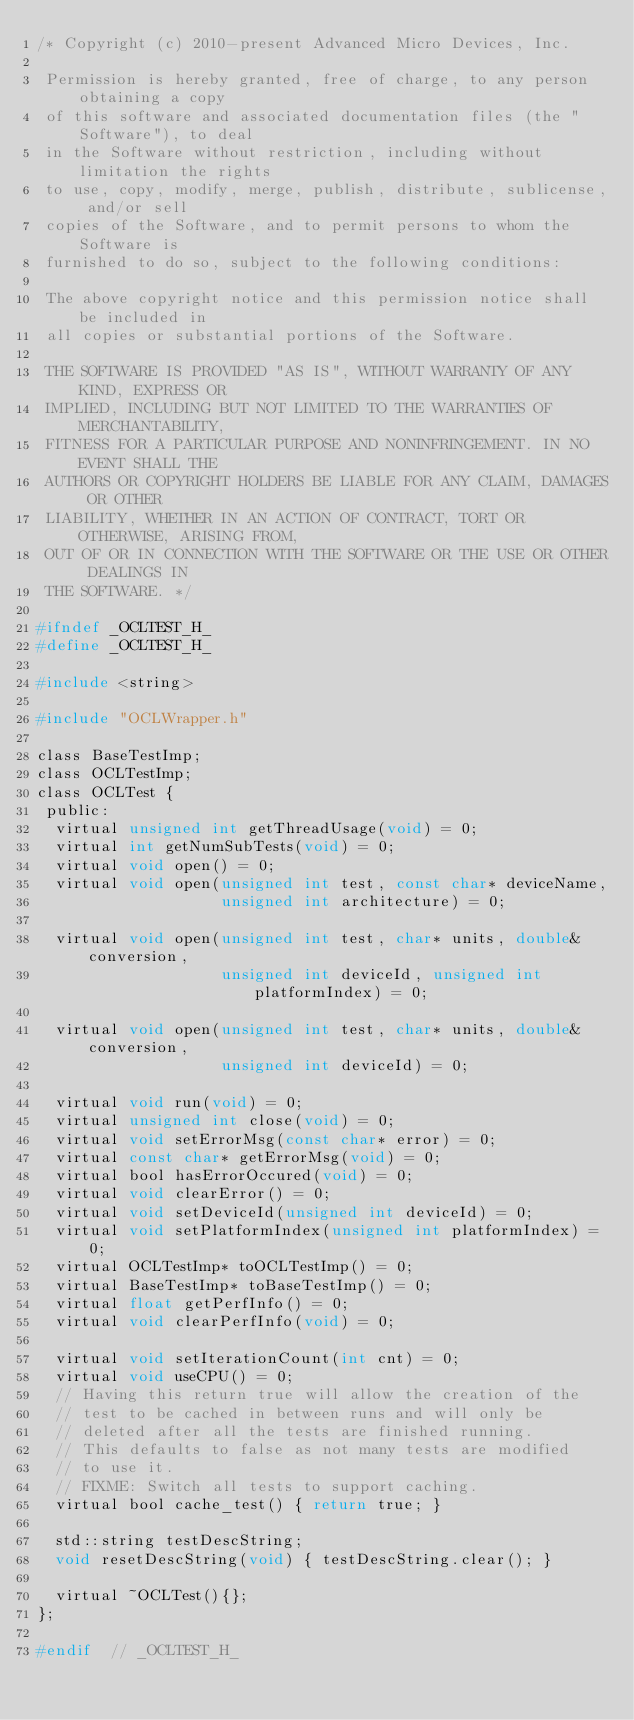<code> <loc_0><loc_0><loc_500><loc_500><_C_>/* Copyright (c) 2010-present Advanced Micro Devices, Inc.

 Permission is hereby granted, free of charge, to any person obtaining a copy
 of this software and associated documentation files (the "Software"), to deal
 in the Software without restriction, including without limitation the rights
 to use, copy, modify, merge, publish, distribute, sublicense, and/or sell
 copies of the Software, and to permit persons to whom the Software is
 furnished to do so, subject to the following conditions:

 The above copyright notice and this permission notice shall be included in
 all copies or substantial portions of the Software.

 THE SOFTWARE IS PROVIDED "AS IS", WITHOUT WARRANTY OF ANY KIND, EXPRESS OR
 IMPLIED, INCLUDING BUT NOT LIMITED TO THE WARRANTIES OF MERCHANTABILITY,
 FITNESS FOR A PARTICULAR PURPOSE AND NONINFRINGEMENT. IN NO EVENT SHALL THE
 AUTHORS OR COPYRIGHT HOLDERS BE LIABLE FOR ANY CLAIM, DAMAGES OR OTHER
 LIABILITY, WHETHER IN AN ACTION OF CONTRACT, TORT OR OTHERWISE, ARISING FROM,
 OUT OF OR IN CONNECTION WITH THE SOFTWARE OR THE USE OR OTHER DEALINGS IN
 THE SOFTWARE. */

#ifndef _OCLTEST_H_
#define _OCLTEST_H_

#include <string>

#include "OCLWrapper.h"

class BaseTestImp;
class OCLTestImp;
class OCLTest {
 public:
  virtual unsigned int getThreadUsage(void) = 0;
  virtual int getNumSubTests(void) = 0;
  virtual void open() = 0;
  virtual void open(unsigned int test, const char* deviceName,
                    unsigned int architecture) = 0;

  virtual void open(unsigned int test, char* units, double& conversion,
                    unsigned int deviceId, unsigned int platformIndex) = 0;

  virtual void open(unsigned int test, char* units, double& conversion,
                    unsigned int deviceId) = 0;

  virtual void run(void) = 0;
  virtual unsigned int close(void) = 0;
  virtual void setErrorMsg(const char* error) = 0;
  virtual const char* getErrorMsg(void) = 0;
  virtual bool hasErrorOccured(void) = 0;
  virtual void clearError() = 0;
  virtual void setDeviceId(unsigned int deviceId) = 0;
  virtual void setPlatformIndex(unsigned int platformIndex) = 0;
  virtual OCLTestImp* toOCLTestImp() = 0;
  virtual BaseTestImp* toBaseTestImp() = 0;
  virtual float getPerfInfo() = 0;
  virtual void clearPerfInfo(void) = 0;

  virtual void setIterationCount(int cnt) = 0;
  virtual void useCPU() = 0;
  // Having this return true will allow the creation of the
  // test to be cached in between runs and will only be
  // deleted after all the tests are finished running.
  // This defaults to false as not many tests are modified
  // to use it.
  // FIXME: Switch all tests to support caching.
  virtual bool cache_test() { return true; }

  std::string testDescString;
  void resetDescString(void) { testDescString.clear(); }

  virtual ~OCLTest(){};
};

#endif  // _OCLTEST_H_
</code> 